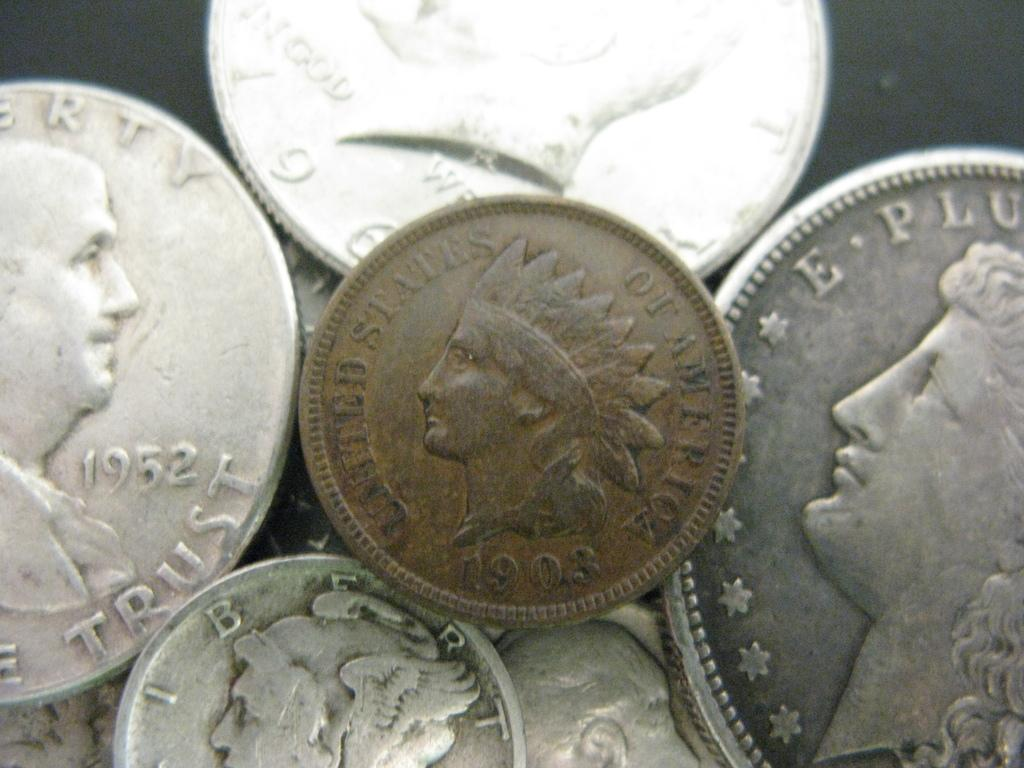Provide a one-sentence caption for the provided image. A collection of silver colored coins and one bronze colored one from 1903. 